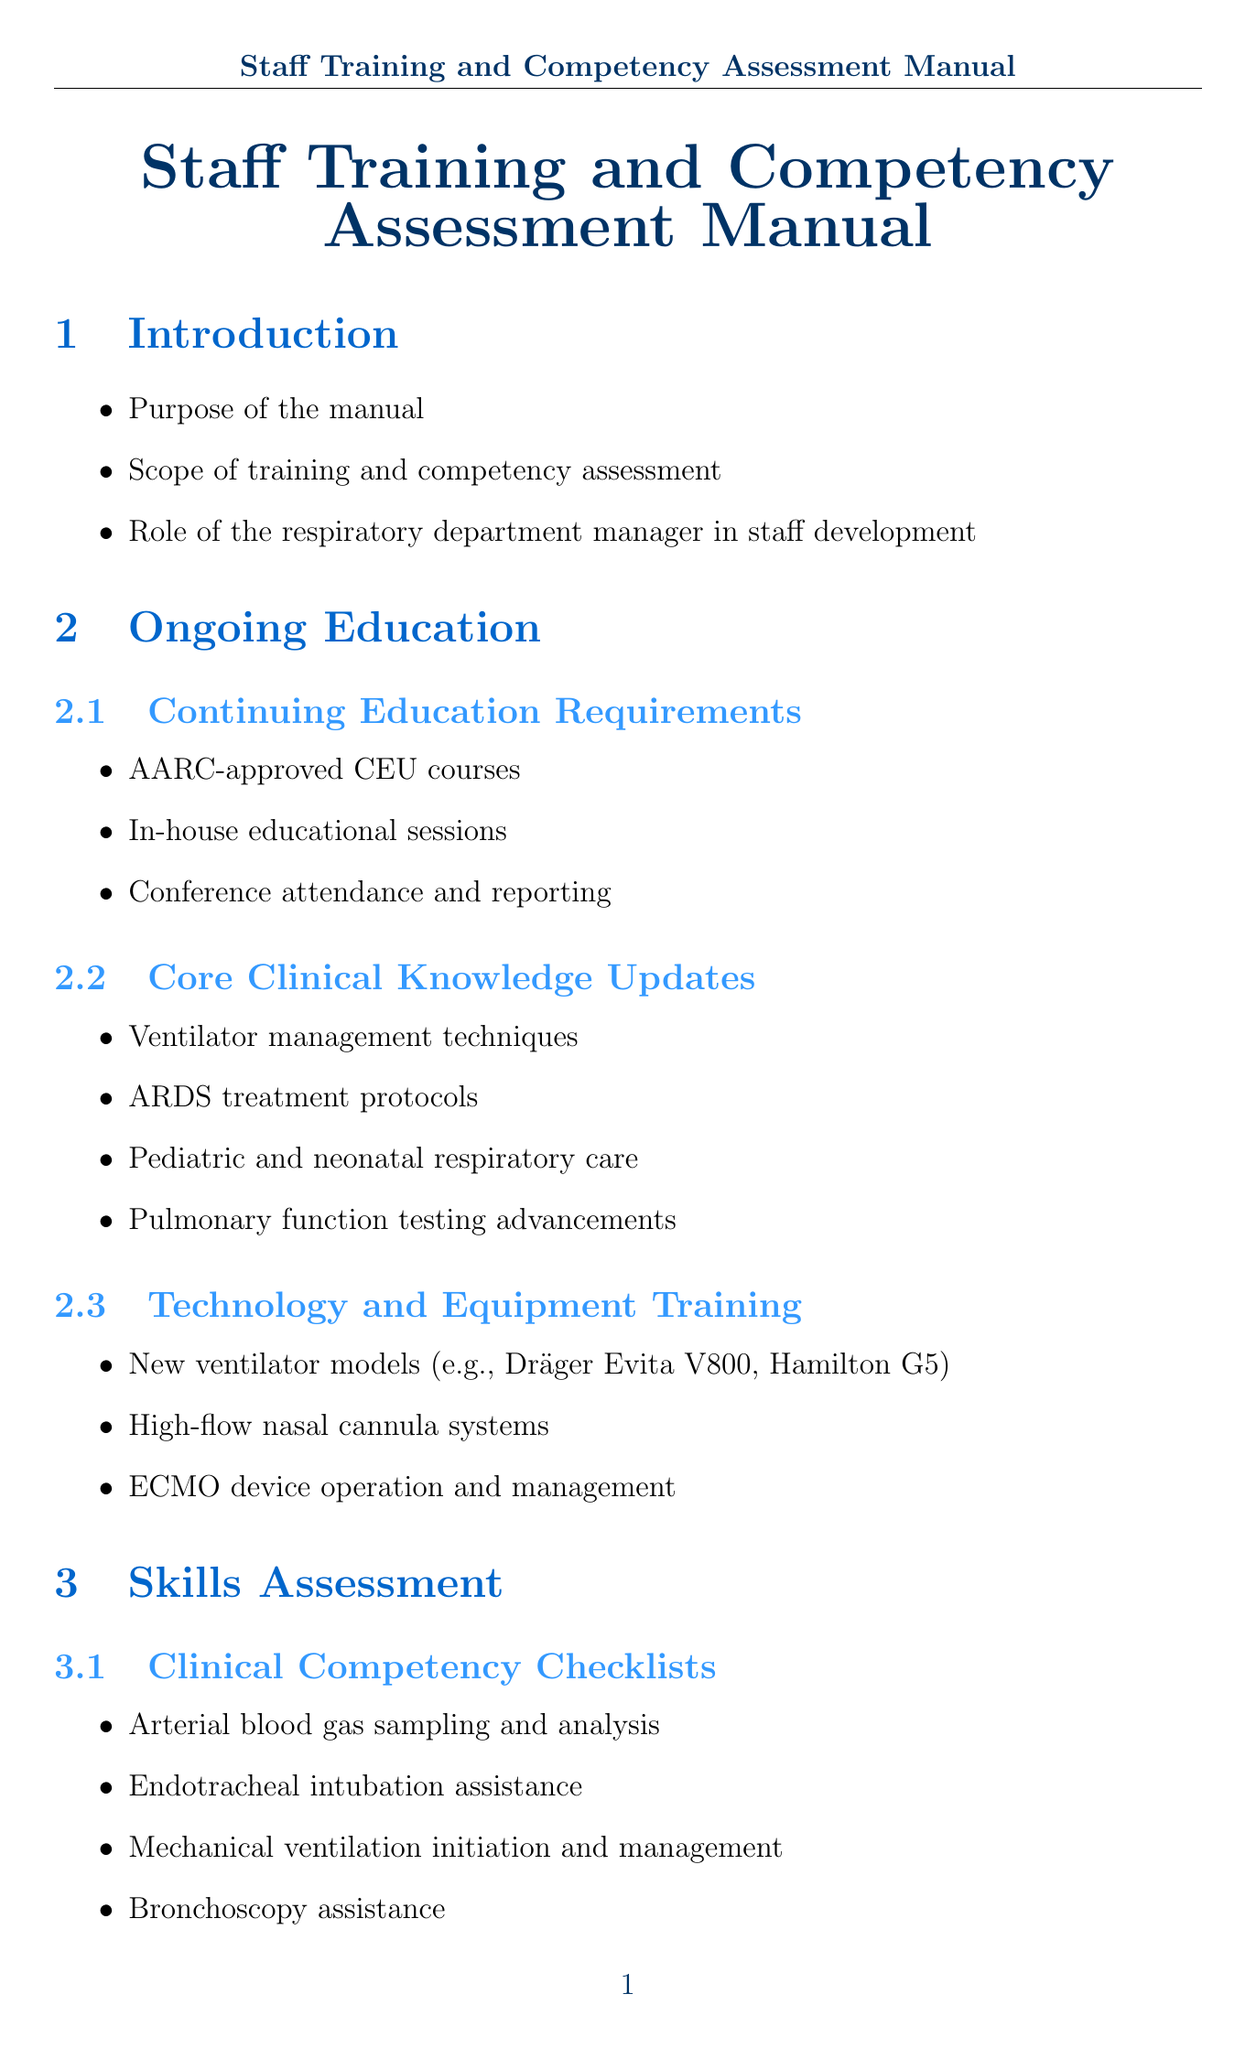What is the purpose of the manual? The purpose of the manual is to outline the training and competency assessment curriculum for respiratory therapists.
Answer: Outline training and competency assessment curriculum What is one topic covered under continuing education requirements? Continuing education requirements include topics such as AARC-approved CEU courses.
Answer: AARC-approved CEU courses Name a simulation scenario listed in the skills assessment section. One simulation scenario listed is acute respiratory distress in the emergency department.
Answer: Acute respiratory distress in the emergency department What is a method used for performance evaluations? One method used for performance evaluations is direct observation by clinical educators.
Answer: Direct observation by clinical educators How many specialty certifications are mentioned? There are four specialty certifications mentioned in the document.
Answer: Four What does PPE stand for in infection control practices? PPE stands for personal protective equipment in infection control practices.
Answer: Personal protective equipment What is one quality metric tracked in the documentation and reporting section? One quality metric tracked is ventilator-associated pneumonia rates.
Answer: Ventilator-associated pneumonia rates What regulatory body's standards are referenced in the compliance and safety section? The regulatory body's standards referenced are those of the Joint Commission.
Answer: Joint Commission What is a type of emergency preparedness drill mentioned? A type of emergency preparedness drill mentioned is mass casualty incident response.
Answer: Mass casualty incident response 